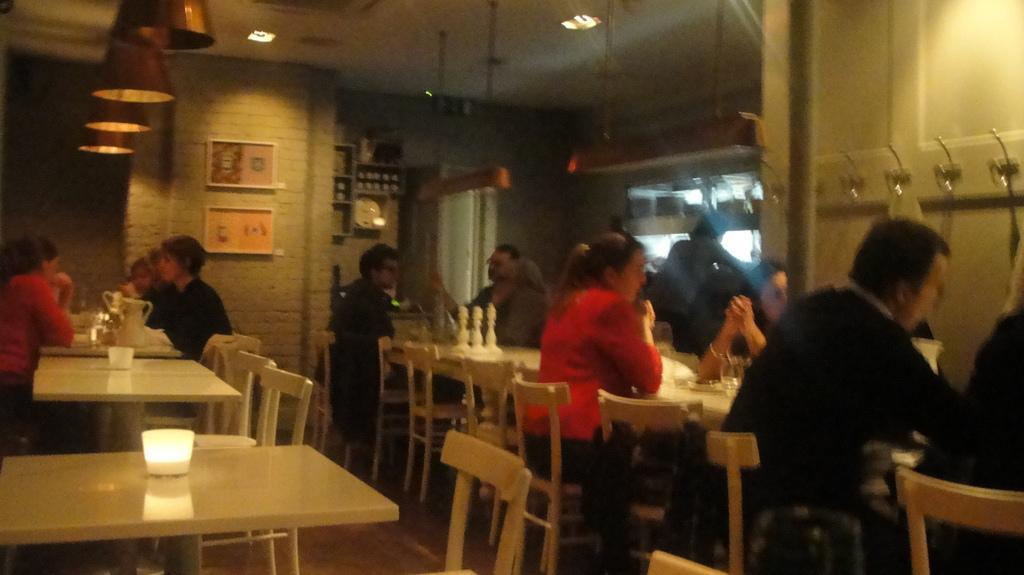In one or two sentences, can you explain what this image depicts? In this picture there are group of people setting the have a table in front of them and also there is a kettle, water jug, glasses, spoons, napkins, food served with plates and there is a wall in the backdrop with some photo frames on it 